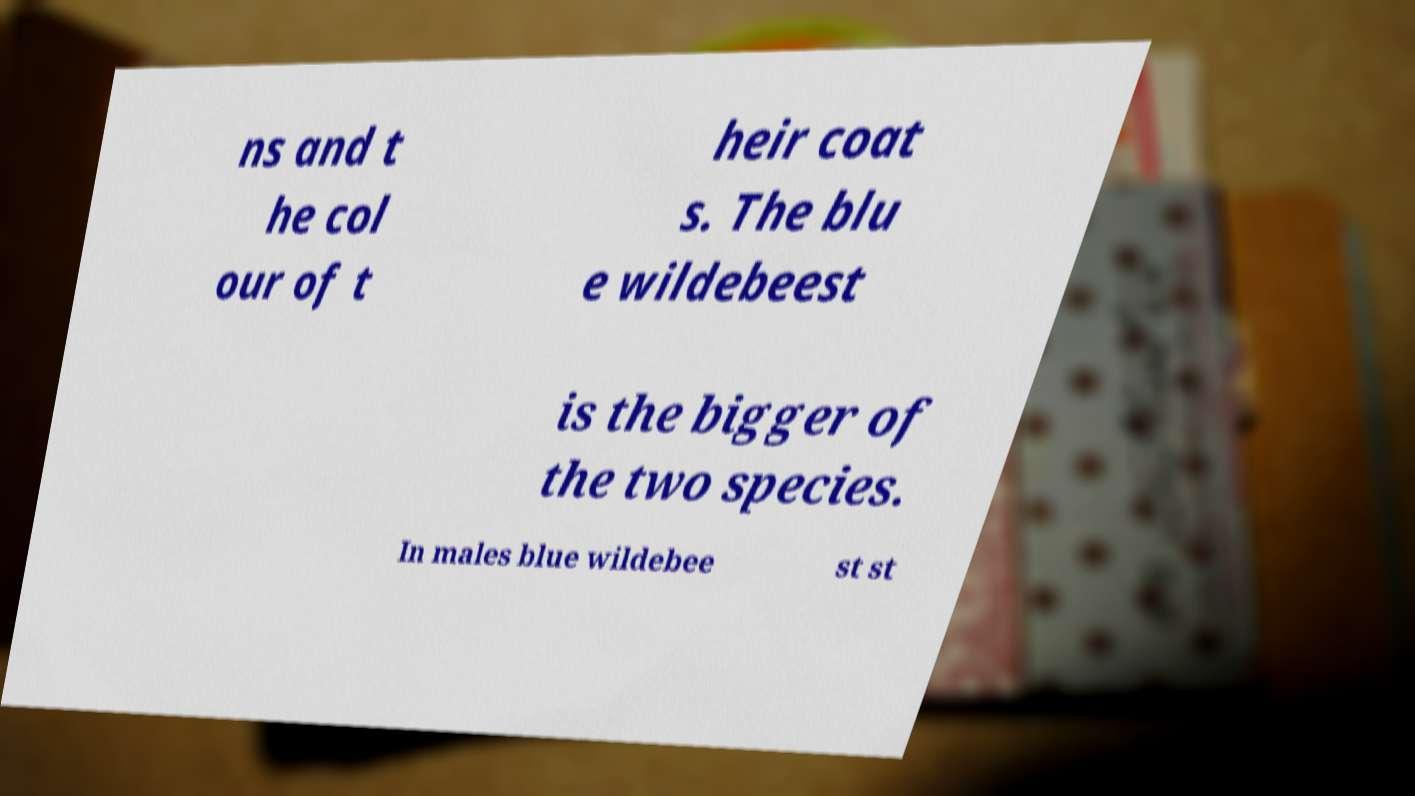Could you assist in decoding the text presented in this image and type it out clearly? ns and t he col our of t heir coat s. The blu e wildebeest is the bigger of the two species. In males blue wildebee st st 